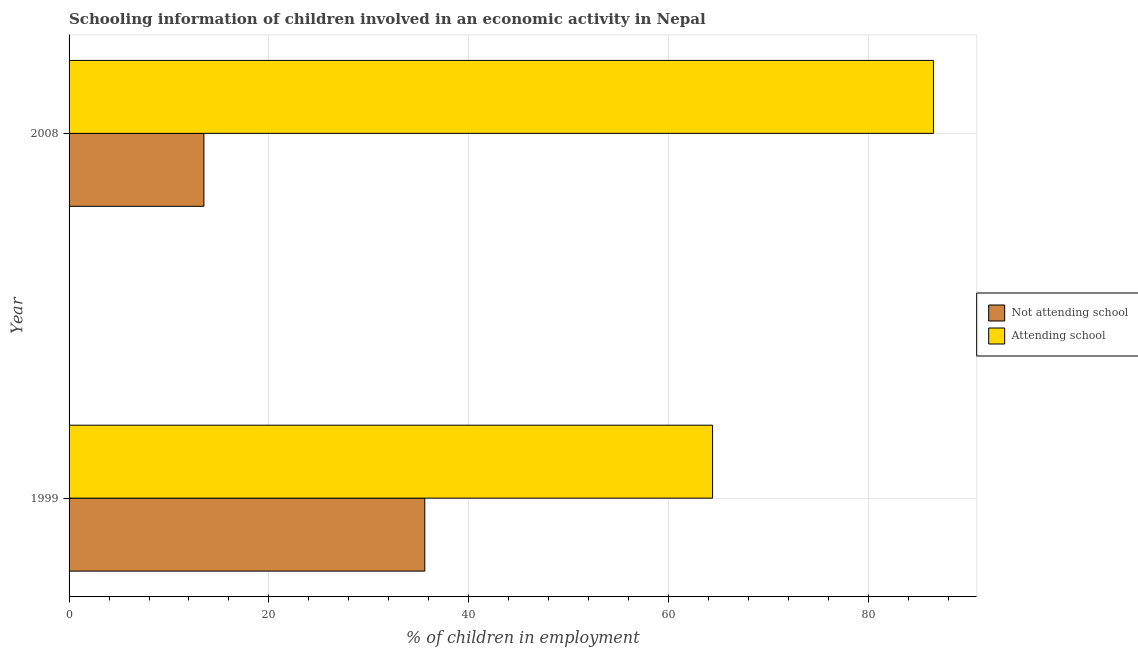How many groups of bars are there?
Your response must be concise. 2. How many bars are there on the 2nd tick from the bottom?
Ensure brevity in your answer.  2. What is the label of the 2nd group of bars from the top?
Your response must be concise. 1999. In how many cases, is the number of bars for a given year not equal to the number of legend labels?
Offer a terse response. 0. What is the percentage of employed children who are attending school in 2008?
Offer a terse response. 86.51. Across all years, what is the maximum percentage of employed children who are attending school?
Make the answer very short. 86.51. Across all years, what is the minimum percentage of employed children who are attending school?
Make the answer very short. 64.4. What is the total percentage of employed children who are attending school in the graph?
Your answer should be very brief. 150.91. What is the difference between the percentage of employed children who are not attending school in 1999 and that in 2008?
Give a very brief answer. 22.11. What is the difference between the percentage of employed children who are not attending school in 2008 and the percentage of employed children who are attending school in 1999?
Your answer should be very brief. -50.91. What is the average percentage of employed children who are not attending school per year?
Provide a succinct answer. 24.55. In the year 2008, what is the difference between the percentage of employed children who are attending school and percentage of employed children who are not attending school?
Offer a terse response. 73.01. What is the ratio of the percentage of employed children who are not attending school in 1999 to that in 2008?
Offer a terse response. 2.64. Is the percentage of employed children who are attending school in 1999 less than that in 2008?
Give a very brief answer. Yes. In how many years, is the percentage of employed children who are not attending school greater than the average percentage of employed children who are not attending school taken over all years?
Your response must be concise. 1. What does the 2nd bar from the top in 2008 represents?
Your response must be concise. Not attending school. What does the 1st bar from the bottom in 2008 represents?
Ensure brevity in your answer.  Not attending school. How many bars are there?
Your response must be concise. 4. Are all the bars in the graph horizontal?
Your answer should be very brief. Yes. What is the difference between two consecutive major ticks on the X-axis?
Your response must be concise. 20. Are the values on the major ticks of X-axis written in scientific E-notation?
Ensure brevity in your answer.  No. Does the graph contain any zero values?
Keep it short and to the point. No. Where does the legend appear in the graph?
Your response must be concise. Center right. How are the legend labels stacked?
Ensure brevity in your answer.  Vertical. What is the title of the graph?
Ensure brevity in your answer.  Schooling information of children involved in an economic activity in Nepal. Does "% of gross capital formation" appear as one of the legend labels in the graph?
Provide a succinct answer. No. What is the label or title of the X-axis?
Offer a very short reply. % of children in employment. What is the % of children in employment in Not attending school in 1999?
Offer a terse response. 35.6. What is the % of children in employment in Attending school in 1999?
Provide a succinct answer. 64.4. What is the % of children in employment in Not attending school in 2008?
Offer a terse response. 13.49. What is the % of children in employment in Attending school in 2008?
Your answer should be very brief. 86.51. Across all years, what is the maximum % of children in employment in Not attending school?
Your response must be concise. 35.6. Across all years, what is the maximum % of children in employment of Attending school?
Offer a very short reply. 86.51. Across all years, what is the minimum % of children in employment in Not attending school?
Your answer should be very brief. 13.49. Across all years, what is the minimum % of children in employment of Attending school?
Provide a short and direct response. 64.4. What is the total % of children in employment of Not attending school in the graph?
Your response must be concise. 49.09. What is the total % of children in employment in Attending school in the graph?
Your response must be concise. 150.91. What is the difference between the % of children in employment in Not attending school in 1999 and that in 2008?
Give a very brief answer. 22.11. What is the difference between the % of children in employment of Attending school in 1999 and that in 2008?
Offer a very short reply. -22.11. What is the difference between the % of children in employment of Not attending school in 1999 and the % of children in employment of Attending school in 2008?
Give a very brief answer. -50.91. What is the average % of children in employment in Not attending school per year?
Ensure brevity in your answer.  24.55. What is the average % of children in employment in Attending school per year?
Your answer should be compact. 75.45. In the year 1999, what is the difference between the % of children in employment of Not attending school and % of children in employment of Attending school?
Ensure brevity in your answer.  -28.8. In the year 2008, what is the difference between the % of children in employment of Not attending school and % of children in employment of Attending school?
Provide a succinct answer. -73.01. What is the ratio of the % of children in employment of Not attending school in 1999 to that in 2008?
Offer a terse response. 2.64. What is the ratio of the % of children in employment in Attending school in 1999 to that in 2008?
Provide a succinct answer. 0.74. What is the difference between the highest and the second highest % of children in employment in Not attending school?
Keep it short and to the point. 22.11. What is the difference between the highest and the second highest % of children in employment in Attending school?
Give a very brief answer. 22.11. What is the difference between the highest and the lowest % of children in employment in Not attending school?
Provide a short and direct response. 22.11. What is the difference between the highest and the lowest % of children in employment of Attending school?
Your answer should be very brief. 22.11. 